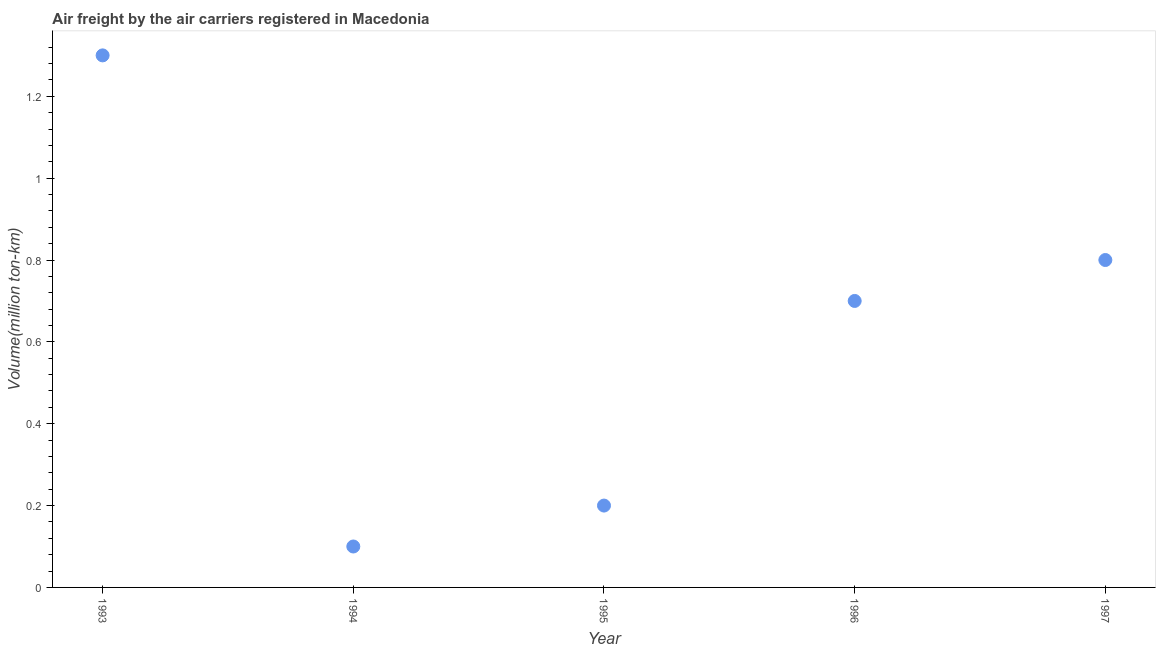What is the air freight in 1995?
Provide a short and direct response. 0.2. Across all years, what is the maximum air freight?
Your answer should be compact. 1.3. Across all years, what is the minimum air freight?
Give a very brief answer. 0.1. In which year was the air freight minimum?
Keep it short and to the point. 1994. What is the sum of the air freight?
Offer a terse response. 3.1. What is the difference between the air freight in 1995 and 1997?
Offer a very short reply. -0.6. What is the average air freight per year?
Make the answer very short. 0.62. What is the median air freight?
Provide a succinct answer. 0.7. Do a majority of the years between 1995 and 1997 (inclusive) have air freight greater than 0.44 million ton-km?
Offer a terse response. Yes. What is the ratio of the air freight in 1993 to that in 1994?
Offer a terse response. 13. What is the difference between the highest and the second highest air freight?
Give a very brief answer. 0.5. What is the difference between the highest and the lowest air freight?
Offer a terse response. 1.2. In how many years, is the air freight greater than the average air freight taken over all years?
Make the answer very short. 3. Does the air freight monotonically increase over the years?
Your response must be concise. No. What is the difference between two consecutive major ticks on the Y-axis?
Provide a succinct answer. 0.2. Does the graph contain grids?
Provide a succinct answer. No. What is the title of the graph?
Ensure brevity in your answer.  Air freight by the air carriers registered in Macedonia. What is the label or title of the Y-axis?
Provide a succinct answer. Volume(million ton-km). What is the Volume(million ton-km) in 1993?
Make the answer very short. 1.3. What is the Volume(million ton-km) in 1994?
Provide a short and direct response. 0.1. What is the Volume(million ton-km) in 1995?
Offer a very short reply. 0.2. What is the Volume(million ton-km) in 1996?
Provide a succinct answer. 0.7. What is the Volume(million ton-km) in 1997?
Ensure brevity in your answer.  0.8. What is the difference between the Volume(million ton-km) in 1993 and 1994?
Your answer should be very brief. 1.2. What is the difference between the Volume(million ton-km) in 1993 and 1996?
Provide a short and direct response. 0.6. What is the difference between the Volume(million ton-km) in 1993 and 1997?
Your answer should be compact. 0.5. What is the difference between the Volume(million ton-km) in 1994 and 1995?
Your response must be concise. -0.1. What is the difference between the Volume(million ton-km) in 1995 and 1997?
Offer a very short reply. -0.6. What is the ratio of the Volume(million ton-km) in 1993 to that in 1994?
Provide a short and direct response. 13. What is the ratio of the Volume(million ton-km) in 1993 to that in 1995?
Your answer should be compact. 6.5. What is the ratio of the Volume(million ton-km) in 1993 to that in 1996?
Ensure brevity in your answer.  1.86. What is the ratio of the Volume(million ton-km) in 1993 to that in 1997?
Provide a succinct answer. 1.62. What is the ratio of the Volume(million ton-km) in 1994 to that in 1995?
Provide a short and direct response. 0.5. What is the ratio of the Volume(million ton-km) in 1994 to that in 1996?
Provide a short and direct response. 0.14. What is the ratio of the Volume(million ton-km) in 1994 to that in 1997?
Ensure brevity in your answer.  0.12. What is the ratio of the Volume(million ton-km) in 1995 to that in 1996?
Your answer should be very brief. 0.29. What is the ratio of the Volume(million ton-km) in 1996 to that in 1997?
Give a very brief answer. 0.88. 